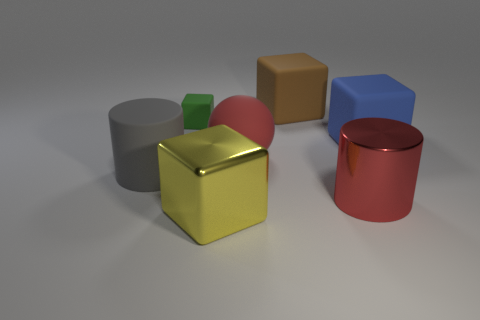Does the big red cylinder have the same material as the big yellow object?
Ensure brevity in your answer.  Yes. Are there any spheres that are in front of the red matte ball that is in front of the matte block that is in front of the green object?
Make the answer very short. No. The tiny block has what color?
Your answer should be compact. Green. What color is the shiny cylinder that is the same size as the shiny block?
Your response must be concise. Red. There is a big matte object that is to the left of the large yellow metal object; does it have the same shape as the large yellow object?
Provide a short and direct response. No. The large rubber cube that is in front of the matte block that is on the left side of the large red thing behind the big red cylinder is what color?
Provide a short and direct response. Blue. Is there a blue matte block?
Provide a succinct answer. Yes. How many other objects are the same size as the green matte object?
Make the answer very short. 0. There is a big matte ball; is its color the same as the block in front of the big red metal cylinder?
Offer a very short reply. No. How many objects are either gray cylinders or small purple balls?
Keep it short and to the point. 1. 